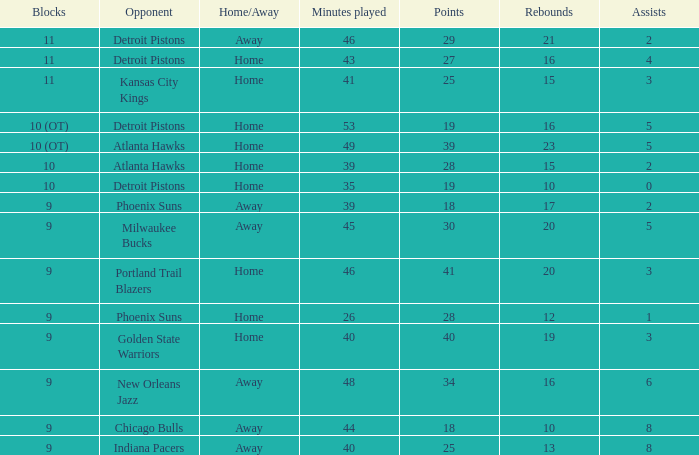What was the point total when there were less than 16 rebounds and 5 assists? 0.0. 